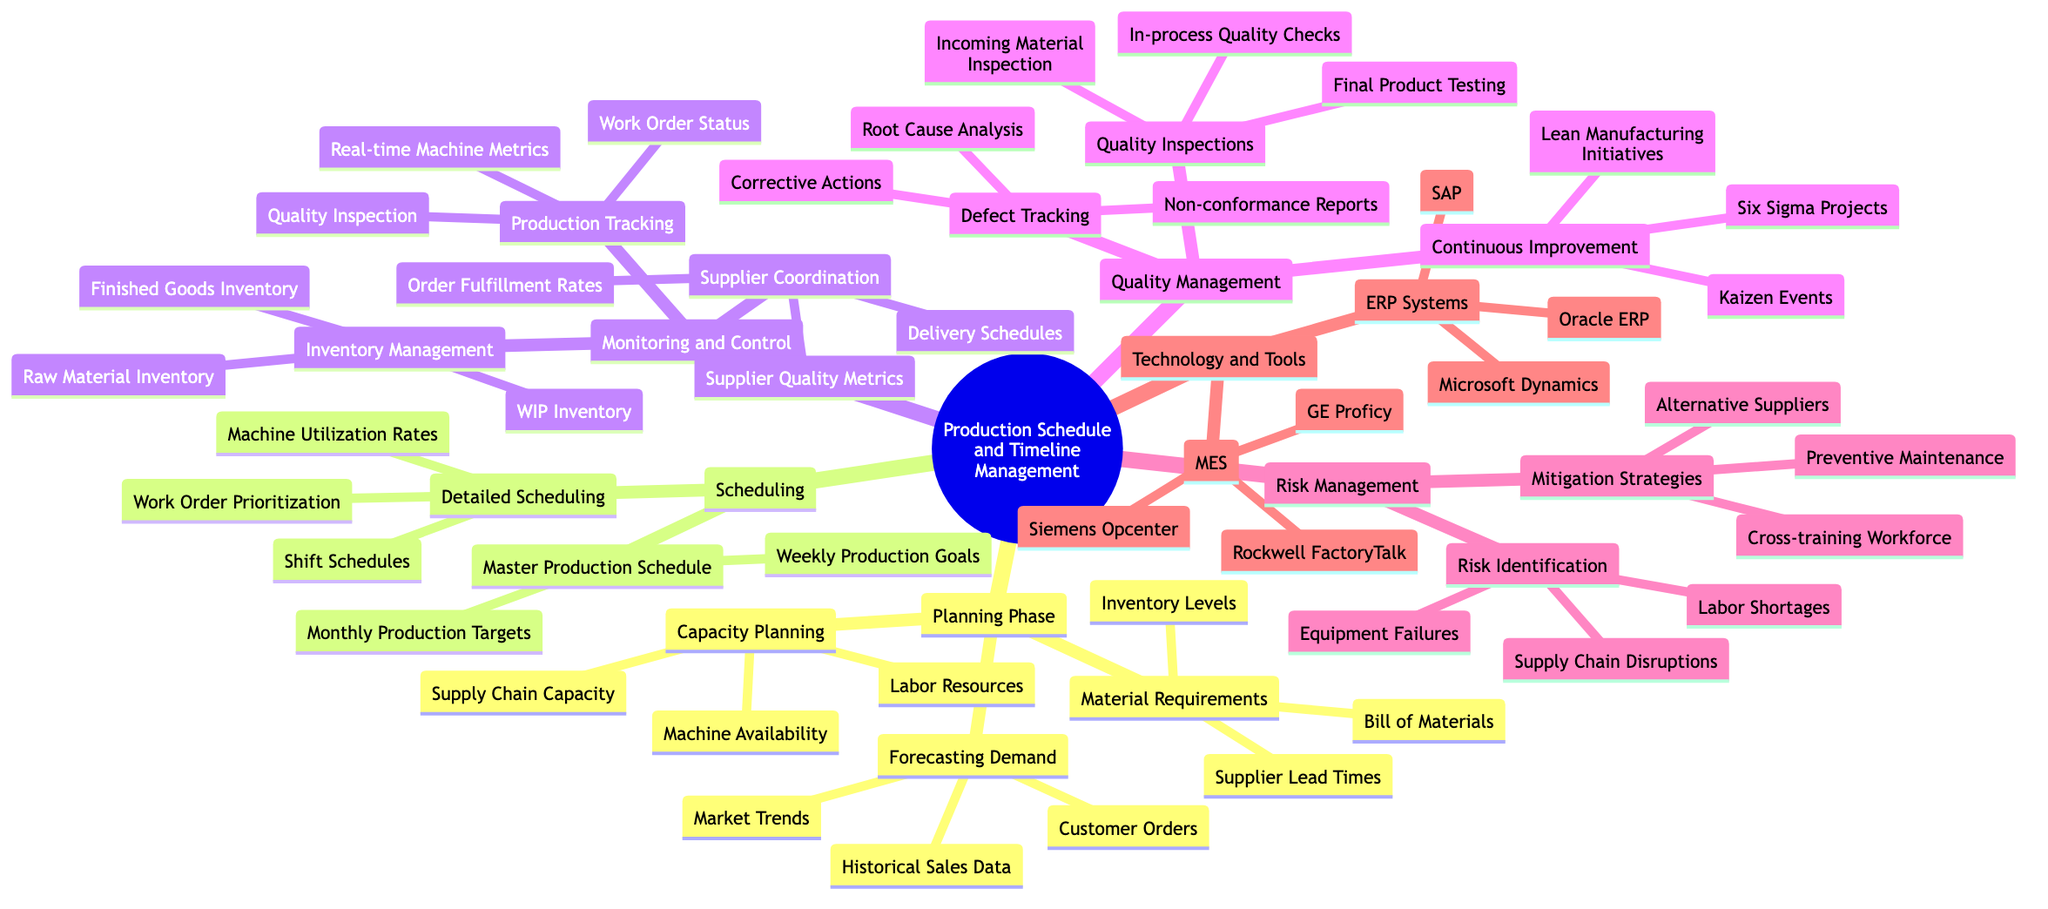What is the first phase of the production schedule management? The diagram indicates that the first phase is "Planning Phase," which is labeled at the top of the relevant section in the mind map.
Answer: Planning Phase How many key areas are covered in the diagram? The diagram lists six main areas: "Planning Phase," "Scheduling," "Monitoring and Control," "Quality Management," "Risk Management," and "Technology and Tools." Counting these top-level categories gives a total of six.
Answer: Six What type of systems are included under Technology and Tools? The "Technology and Tools" section contains two categories: "ERP Systems" and "MES." Both of these are types of systems mentioned in the diagram.
Answer: ERP Systems and MES Which management area includes "Defect Tracking"? “Defect Tracking” is a part of the “Quality Management” area, as can be seen in the relevant section shown in the mind map.
Answer: Quality Management What is one reason identified under Risk Identification? The "Risk Identification" section cites "Supply Chain Disruptions" as one of the risks. This is clearly visible under that category in the diagram.
Answer: Supply Chain Disruptions What is the output of the "Master Production Schedule"? The "Master Production Schedule" aims for "Monthly Production Targets" and "Weekly Production Goals," which are both listed as outputs of this scheduling effort in the diagram.
Answer: Monthly Production Targets and Weekly Production Goals How does "Supplier Coordination" relate to "Inventory Management"? Both "Supplier Coordination" and "Inventory Management" fall under the "Monitoring and Control" category, indicating they are related in the context of managing production and ensuring supply chain efficiency.
Answer: They are both under Monitoring and Control What is one example of a Continuous Improvement initiative? The "Continuous Improvement" section lists "Kaizen Events" as an example of initiatives aimed at continual enhancement in quality management practices.
Answer: Kaizen Events 